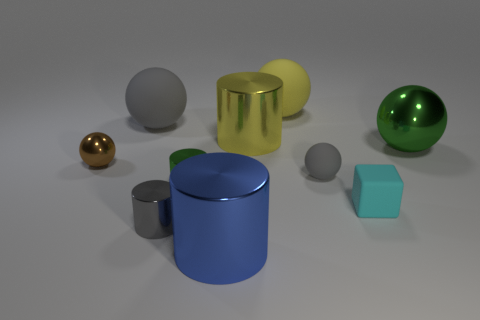What is the material of the large gray thing that is the same shape as the large green thing?
Your response must be concise. Rubber. What number of large objects are metallic things or gray matte blocks?
Keep it short and to the point. 3. Are there fewer tiny cyan rubber blocks right of the small matte cube than blue metallic cylinders on the left side of the small green shiny cylinder?
Your answer should be very brief. No. What number of things are either large cylinders or gray metallic objects?
Offer a very short reply. 3. How many small gray things are behind the gray cylinder?
Your answer should be compact. 1. What is the shape of the big yellow object that is made of the same material as the tiny gray cylinder?
Offer a very short reply. Cylinder. There is a tiny metal object that is in front of the tiny cyan rubber object; does it have the same shape as the yellow metallic thing?
Your response must be concise. Yes. What number of green objects are tiny things or shiny spheres?
Provide a short and direct response. 2. Is the number of small gray matte balls in front of the brown sphere the same as the number of tiny cyan rubber things to the left of the big blue metallic object?
Your response must be concise. No. There is a big sphere behind the gray matte object behind the tiny gray thing that is on the right side of the green metallic cylinder; what is its color?
Make the answer very short. Yellow. 